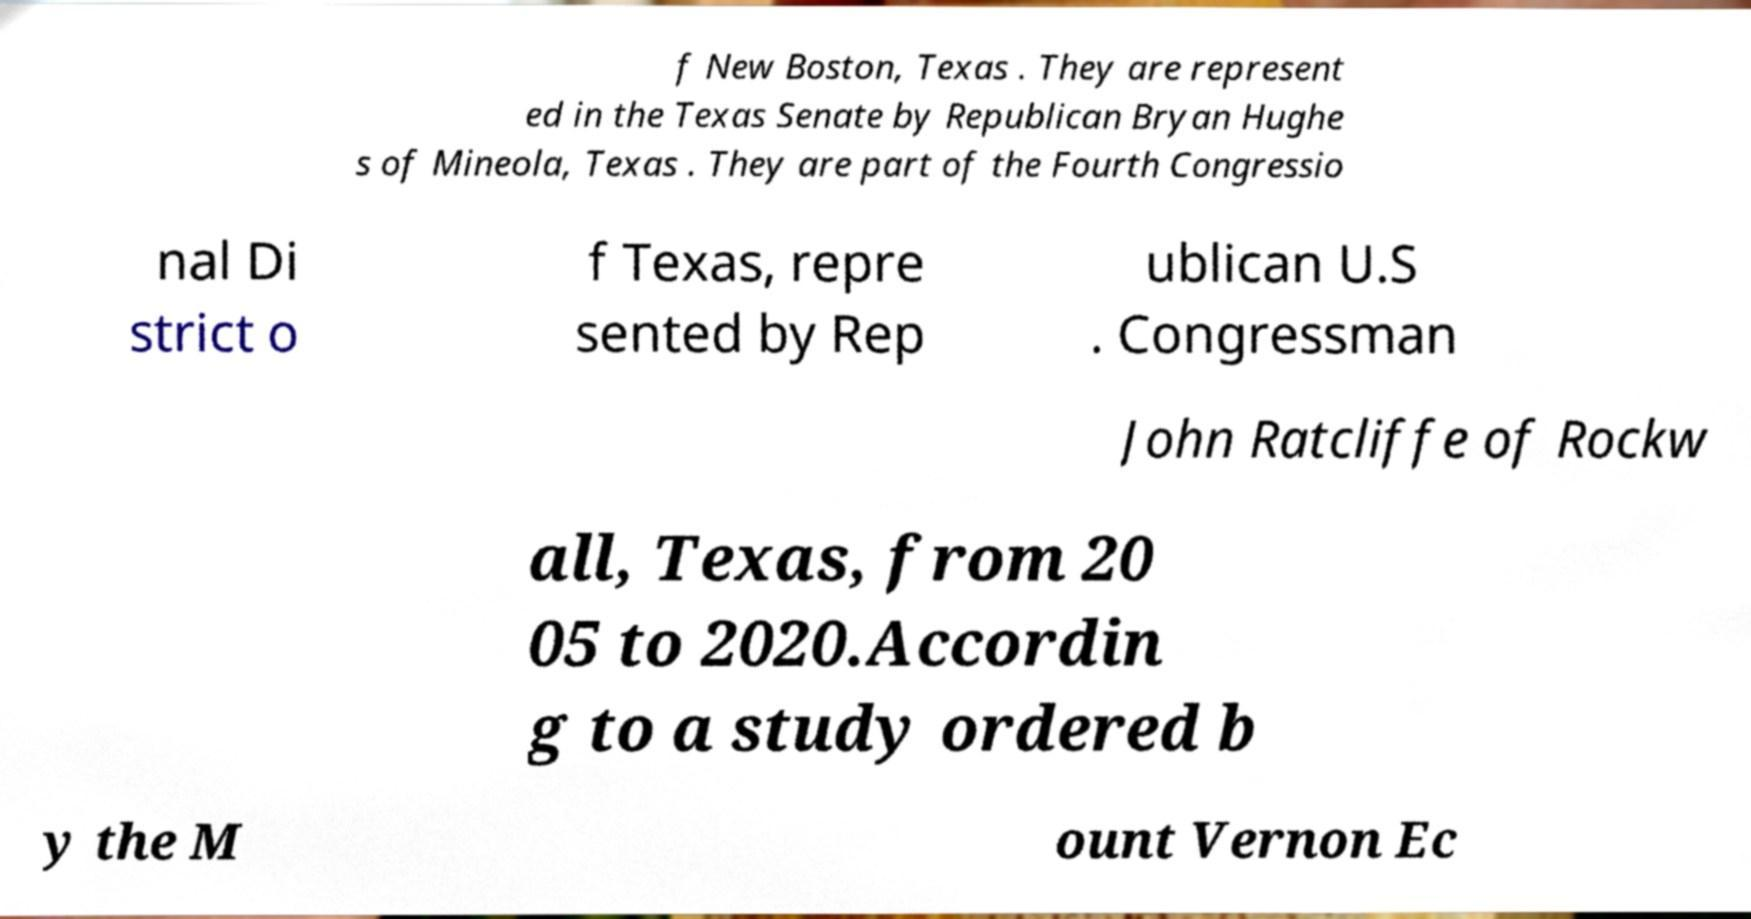Please read and relay the text visible in this image. What does it say? f New Boston, Texas . They are represent ed in the Texas Senate by Republican Bryan Hughe s of Mineola, Texas . They are part of the Fourth Congressio nal Di strict o f Texas, repre sented by Rep ublican U.S . Congressman John Ratcliffe of Rockw all, Texas, from 20 05 to 2020.Accordin g to a study ordered b y the M ount Vernon Ec 